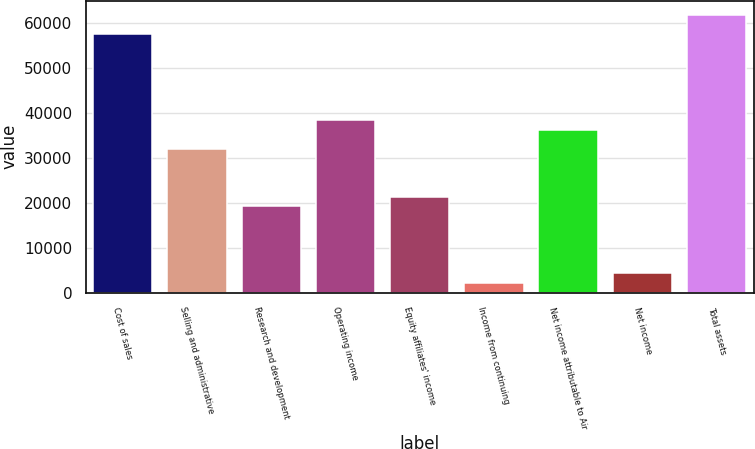<chart> <loc_0><loc_0><loc_500><loc_500><bar_chart><fcel>Cost of sales<fcel>Selling and administrative<fcel>Research and development<fcel>Operating income<fcel>Equity affiliates' income<fcel>Income from continuing<fcel>Net income attributable to Air<fcel>Net income<fcel>Total assets<nl><fcel>57505.8<fcel>31948.8<fcel>19170.2<fcel>38338<fcel>21300<fcel>2132.25<fcel>36208.2<fcel>4262<fcel>61765.2<nl></chart> 